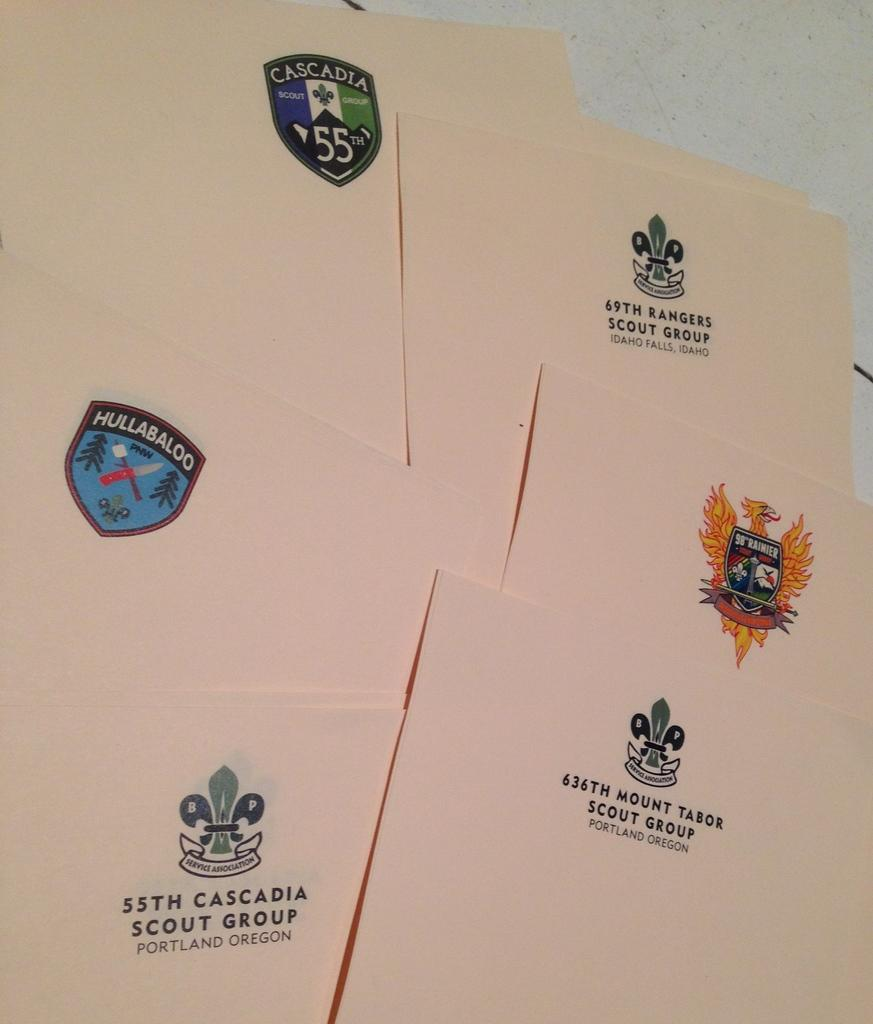Provide a one-sentence caption for the provided image. Several letterheaded papers are from varying locations, including Portland, Oregon. 